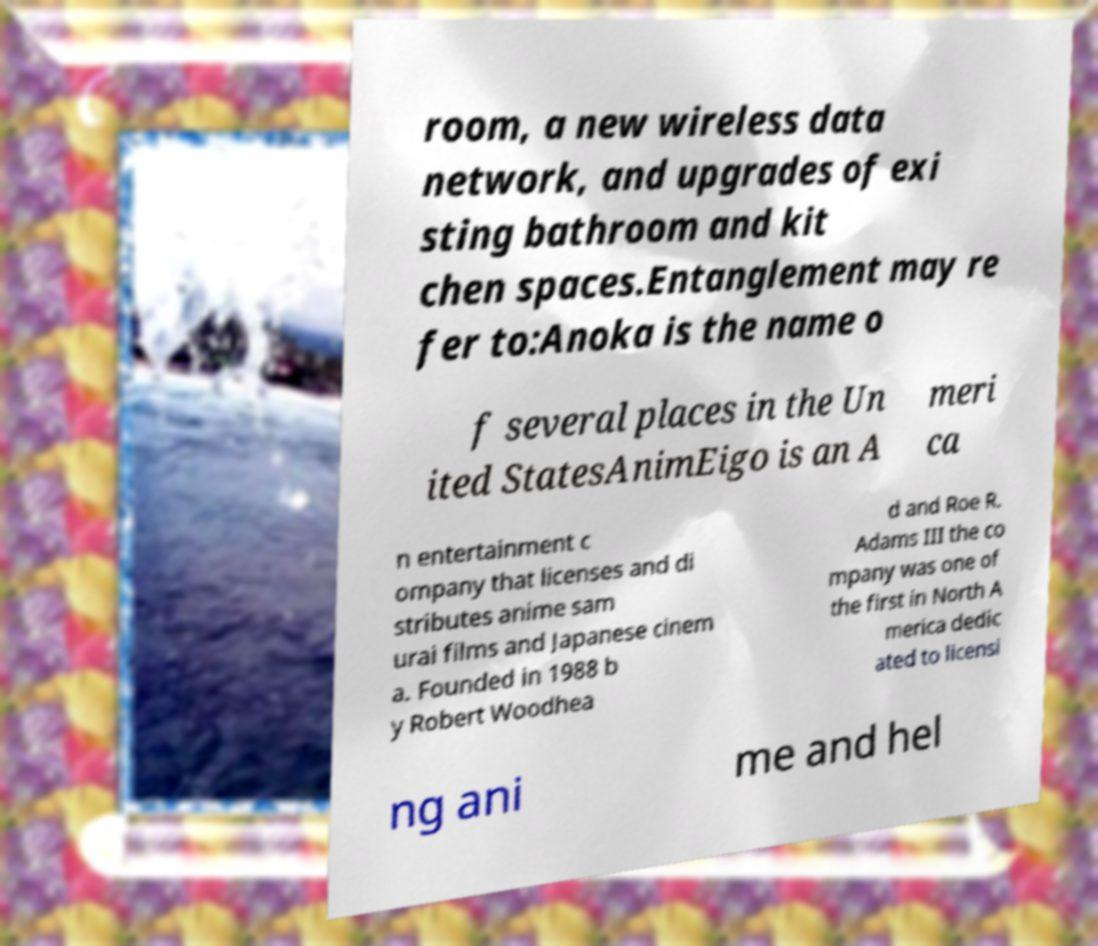Could you extract and type out the text from this image? room, a new wireless data network, and upgrades of exi sting bathroom and kit chen spaces.Entanglement may re fer to:Anoka is the name o f several places in the Un ited StatesAnimEigo is an A meri ca n entertainment c ompany that licenses and di stributes anime sam urai films and Japanese cinem a. Founded in 1988 b y Robert Woodhea d and Roe R. Adams III the co mpany was one of the first in North A merica dedic ated to licensi ng ani me and hel 